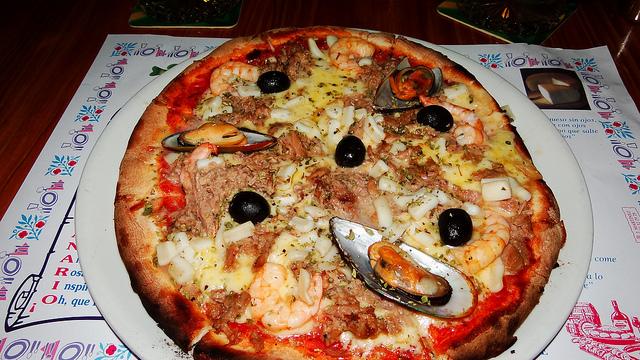What is the pizza sitting on?
Keep it brief. Plate. What color is the table?
Concise answer only. Brown. Are there mussels on the pizza?
Concise answer only. Yes. 